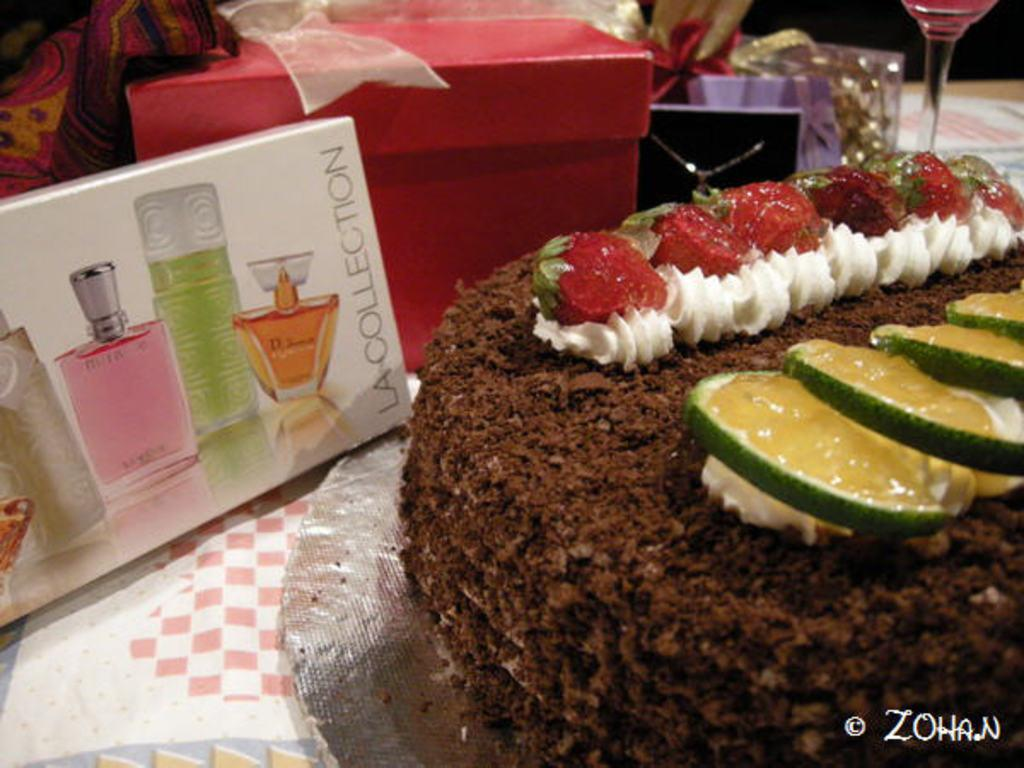Provide a one-sentence caption for the provided image. A box of LaCollection perfume, cake, and presents are on a table. 